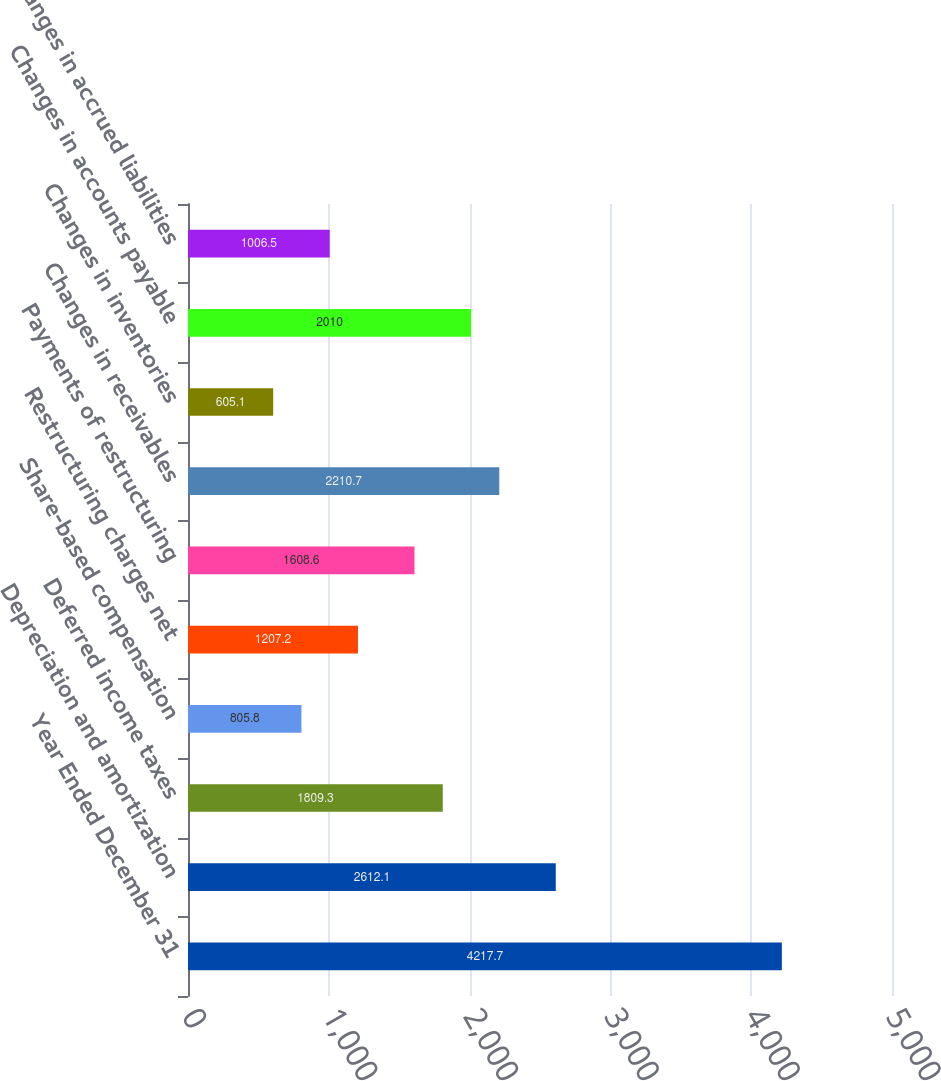<chart> <loc_0><loc_0><loc_500><loc_500><bar_chart><fcel>Year Ended December 31<fcel>Depreciation and amortization<fcel>Deferred income taxes<fcel>Share-based compensation<fcel>Restructuring charges net<fcel>Payments of restructuring<fcel>Changes in receivables<fcel>Changes in inventories<fcel>Changes in accounts payable<fcel>Changes in accrued liabilities<nl><fcel>4217.7<fcel>2612.1<fcel>1809.3<fcel>805.8<fcel>1207.2<fcel>1608.6<fcel>2210.7<fcel>605.1<fcel>2010<fcel>1006.5<nl></chart> 